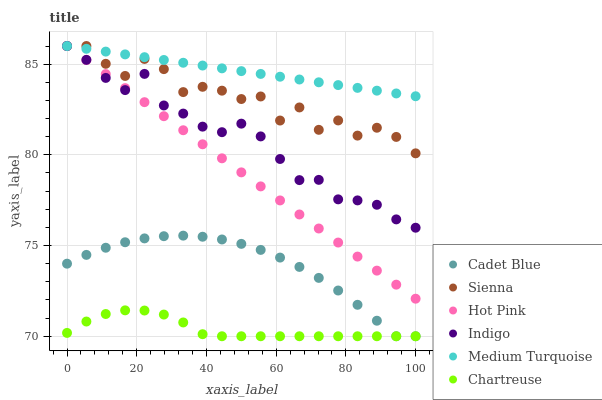Does Chartreuse have the minimum area under the curve?
Answer yes or no. Yes. Does Medium Turquoise have the maximum area under the curve?
Answer yes or no. Yes. Does Indigo have the minimum area under the curve?
Answer yes or no. No. Does Indigo have the maximum area under the curve?
Answer yes or no. No. Is Hot Pink the smoothest?
Answer yes or no. Yes. Is Sienna the roughest?
Answer yes or no. Yes. Is Indigo the smoothest?
Answer yes or no. No. Is Indigo the roughest?
Answer yes or no. No. Does Cadet Blue have the lowest value?
Answer yes or no. Yes. Does Indigo have the lowest value?
Answer yes or no. No. Does Medium Turquoise have the highest value?
Answer yes or no. Yes. Does Chartreuse have the highest value?
Answer yes or no. No. Is Cadet Blue less than Hot Pink?
Answer yes or no. Yes. Is Indigo greater than Cadet Blue?
Answer yes or no. Yes. Does Hot Pink intersect Sienna?
Answer yes or no. Yes. Is Hot Pink less than Sienna?
Answer yes or no. No. Is Hot Pink greater than Sienna?
Answer yes or no. No. Does Cadet Blue intersect Hot Pink?
Answer yes or no. No. 